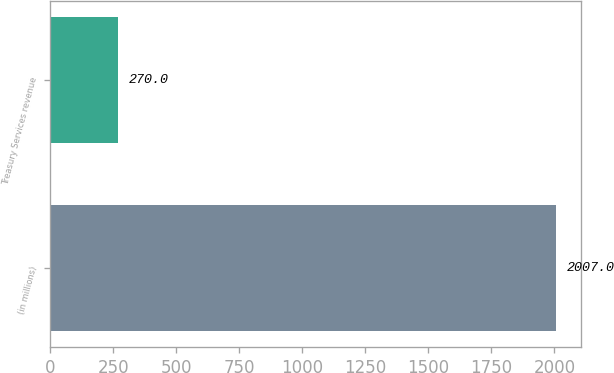Convert chart to OTSL. <chart><loc_0><loc_0><loc_500><loc_500><bar_chart><fcel>(in millions)<fcel>Treasury Services revenue<nl><fcel>2007<fcel>270<nl></chart> 